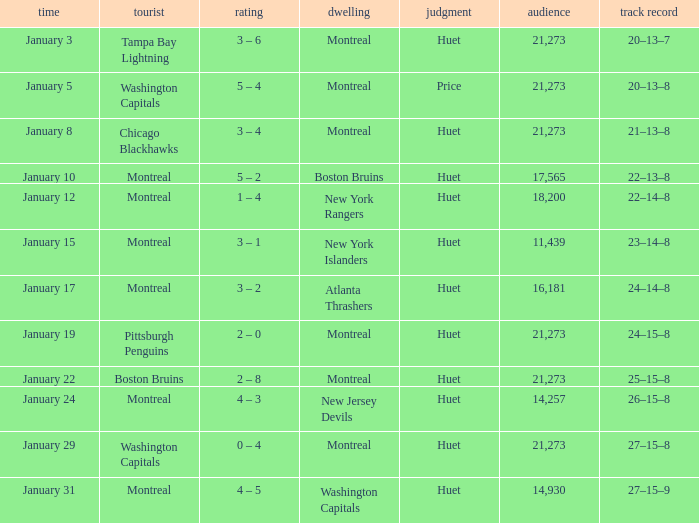What was the date of the game that had a score of 3 – 1? January 15. 